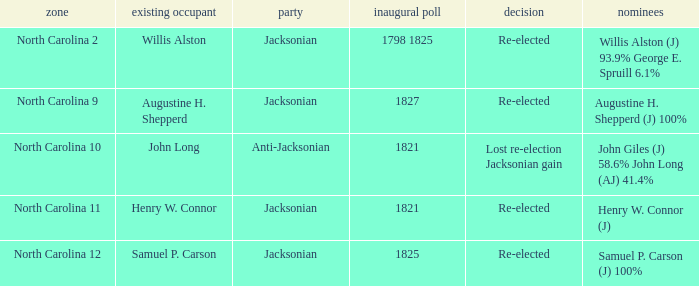Name the result for willis alston Re-elected. 